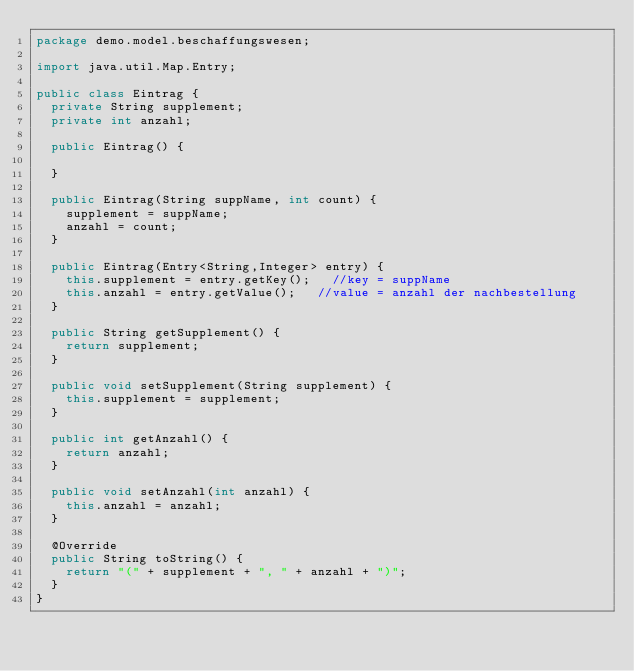Convert code to text. <code><loc_0><loc_0><loc_500><loc_500><_Java_>package demo.model.beschaffungswesen;

import java.util.Map.Entry;

public class Eintrag {
	private String supplement;
	private int anzahl;
	
	public Eintrag() {
		
	}
	
	public Eintrag(String suppName, int count) {
		supplement = suppName;
		anzahl = count;
	}
	
	public Eintrag(Entry<String,Integer> entry) {
		this.supplement = entry.getKey(); 	//key = suppName
		this.anzahl = entry.getValue();		//value = anzahl der nachbestellung 
	}

	public String getSupplement() {
		return supplement;
	}

	public void setSupplement(String supplement) {
		this.supplement = supplement;
	}

	public int getAnzahl() {
		return anzahl;
	}

	public void setAnzahl(int anzahl) {
		this.anzahl = anzahl;
	}
	
	@Override
	public String toString() {
		return "(" + supplement + ", " + anzahl + ")";
	}
}
</code> 